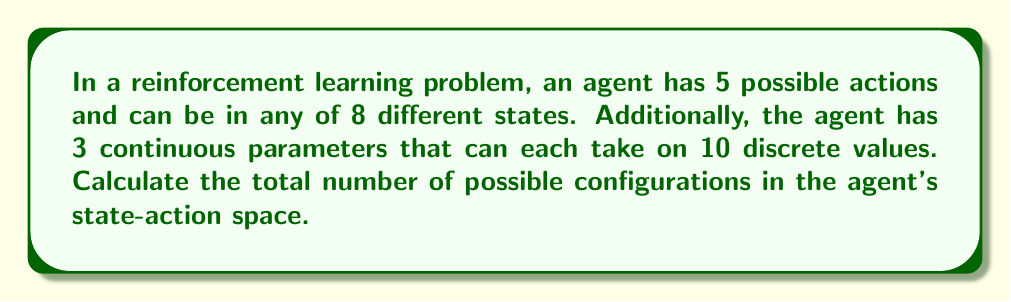Can you answer this question? Let's break this down step-by-step:

1) First, we need to consider the number of possible state-action pairs:
   - There are 8 possible states
   - For each state, there are 5 possible actions
   - So, the number of state-action pairs is: $8 \times 5 = 40$

2) Now, let's consider the continuous parameters:
   - There are 3 parameters
   - Each parameter can take on 10 discrete values
   - This creates $10 \times 10 \times 10 = 1000$ possible parameter configurations

3) For each state-action pair, we can have any of these parameter configurations. Therefore, we need to multiply the number of state-action pairs by the number of parameter configurations:

   $$ \text{Total configurations} = (\text{State-action pairs}) \times (\text{Parameter configurations}) $$
   $$ = 40 \times 1000 = 40,000 $$

Thus, the total number of possible configurations in the agent's state-action space is 40,000.
Answer: 40,000 